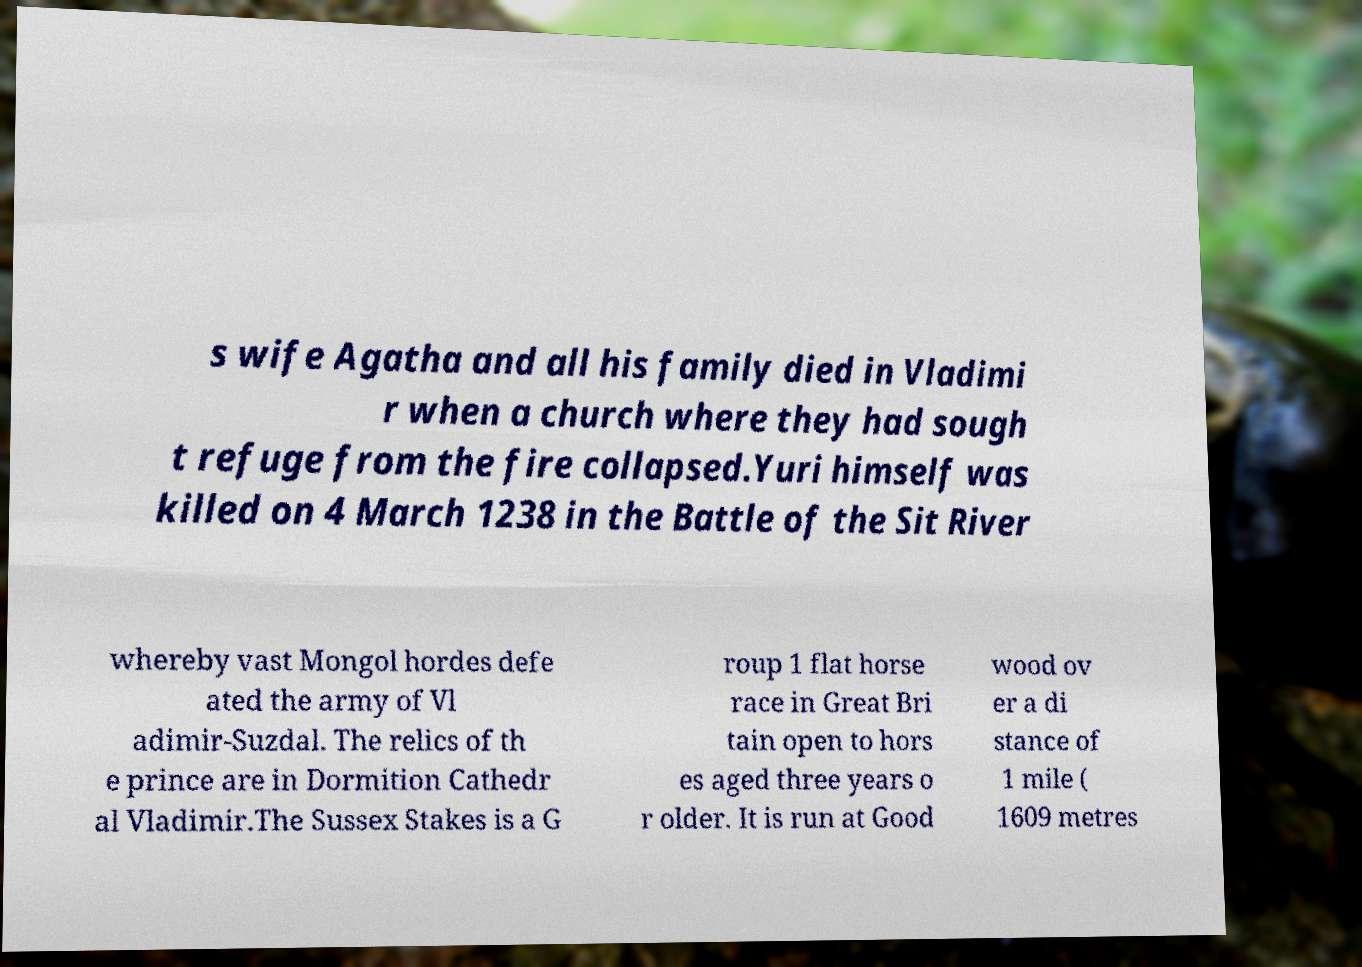Please read and relay the text visible in this image. What does it say? s wife Agatha and all his family died in Vladimi r when a church where they had sough t refuge from the fire collapsed.Yuri himself was killed on 4 March 1238 in the Battle of the Sit River whereby vast Mongol hordes defe ated the army of Vl adimir-Suzdal. The relics of th e prince are in Dormition Cathedr al Vladimir.The Sussex Stakes is a G roup 1 flat horse race in Great Bri tain open to hors es aged three years o r older. It is run at Good wood ov er a di stance of 1 mile ( 1609 metres 